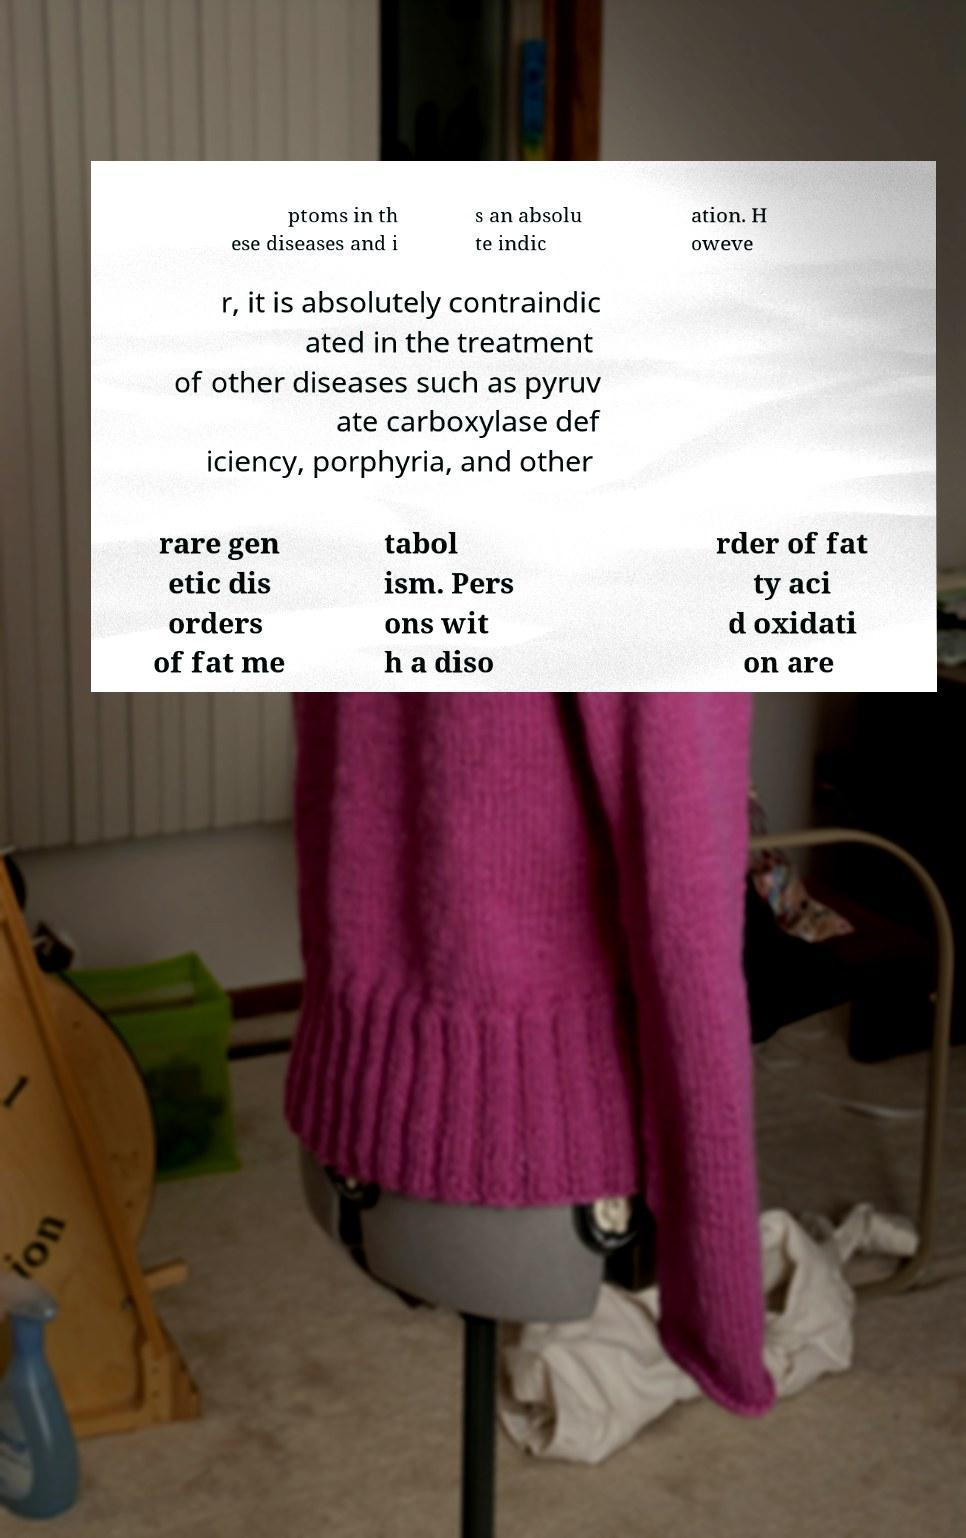Please identify and transcribe the text found in this image. ptoms in th ese diseases and i s an absolu te indic ation. H oweve r, it is absolutely contraindic ated in the treatment of other diseases such as pyruv ate carboxylase def iciency, porphyria, and other rare gen etic dis orders of fat me tabol ism. Pers ons wit h a diso rder of fat ty aci d oxidati on are 